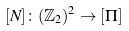Convert formula to latex. <formula><loc_0><loc_0><loc_500><loc_500>[ N ] \colon ( \mathbb { Z } _ { 2 } ) ^ { 2 } \rightarrow [ \Pi ]</formula> 